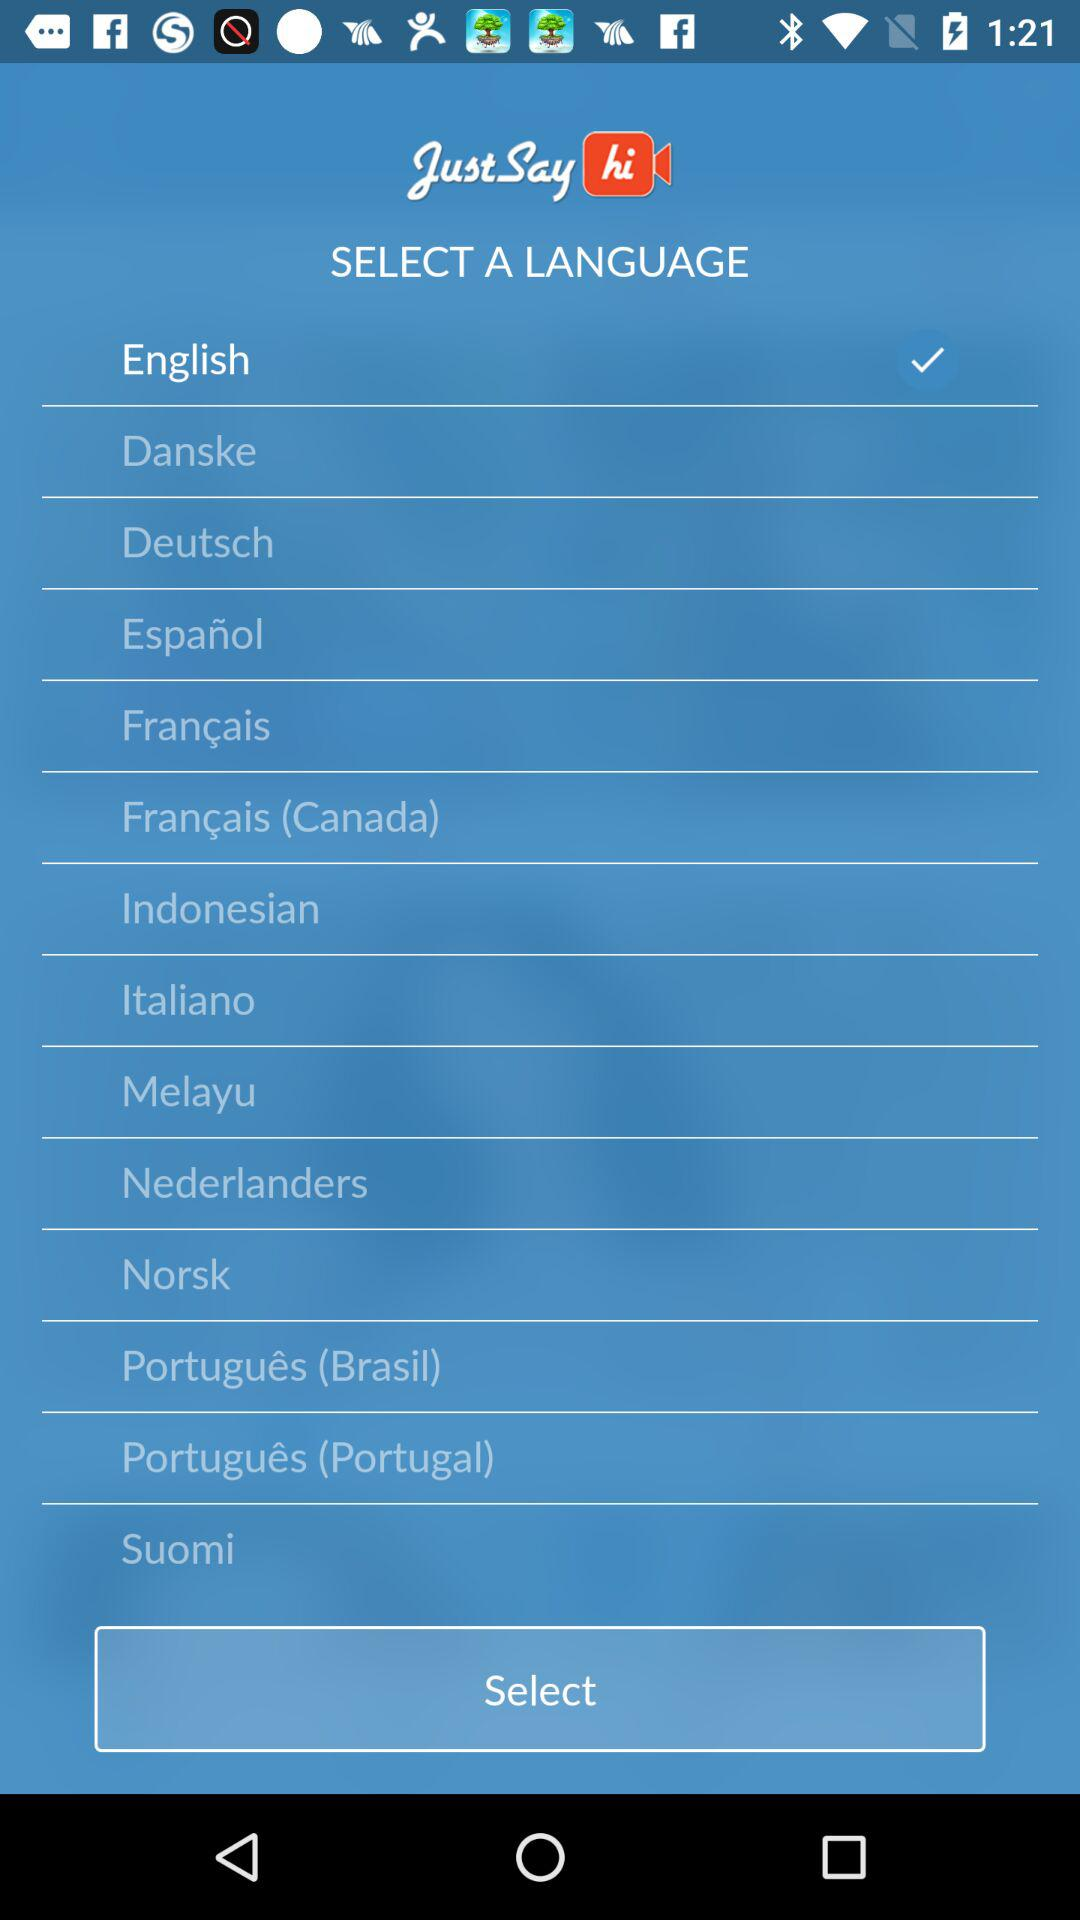Which is the selected language? The selected language is English. 